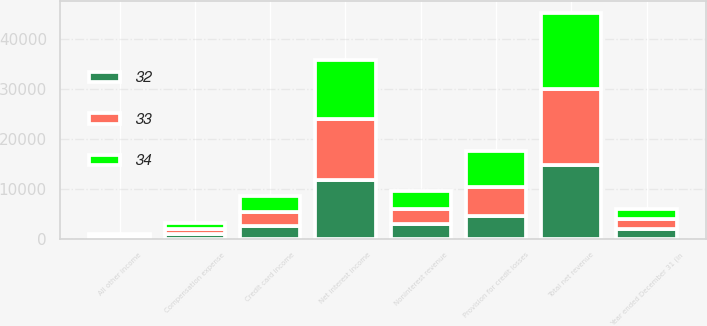<chart> <loc_0><loc_0><loc_500><loc_500><stacked_bar_chart><ecel><fcel>Year ended December 31 (in<fcel>Credit card income<fcel>All other income<fcel>Noninterest revenue<fcel>Net interest income<fcel>Total net revenue<fcel>Provision for credit losses<fcel>Compensation expense<nl><fcel>33<fcel>2007<fcel>2685<fcel>361<fcel>3046<fcel>12189<fcel>15235<fcel>5711<fcel>1021<nl><fcel>32<fcel>2006<fcel>2587<fcel>357<fcel>2944<fcel>11801<fcel>14745<fcel>4598<fcel>1003<nl><fcel>34<fcel>2005<fcel>3351<fcel>212<fcel>3563<fcel>11803<fcel>15366<fcel>7346<fcel>1081<nl></chart> 